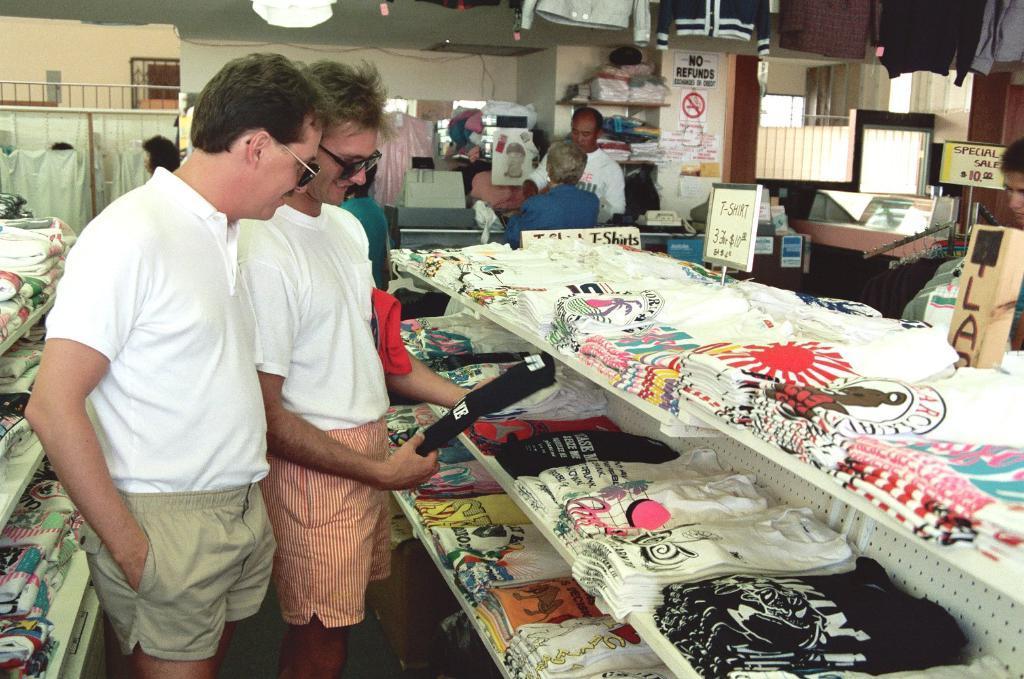Describe this image in one or two sentences. In this image in the front there are persons standing and smiling. On the right side there are clothes and the person in the center is holding a cloth in his hand. On the left side there are shelves and on the shelf there are clothes. In the background there are persons and there are clothes hanging and there are boards with some text written on it and there is a wall. 